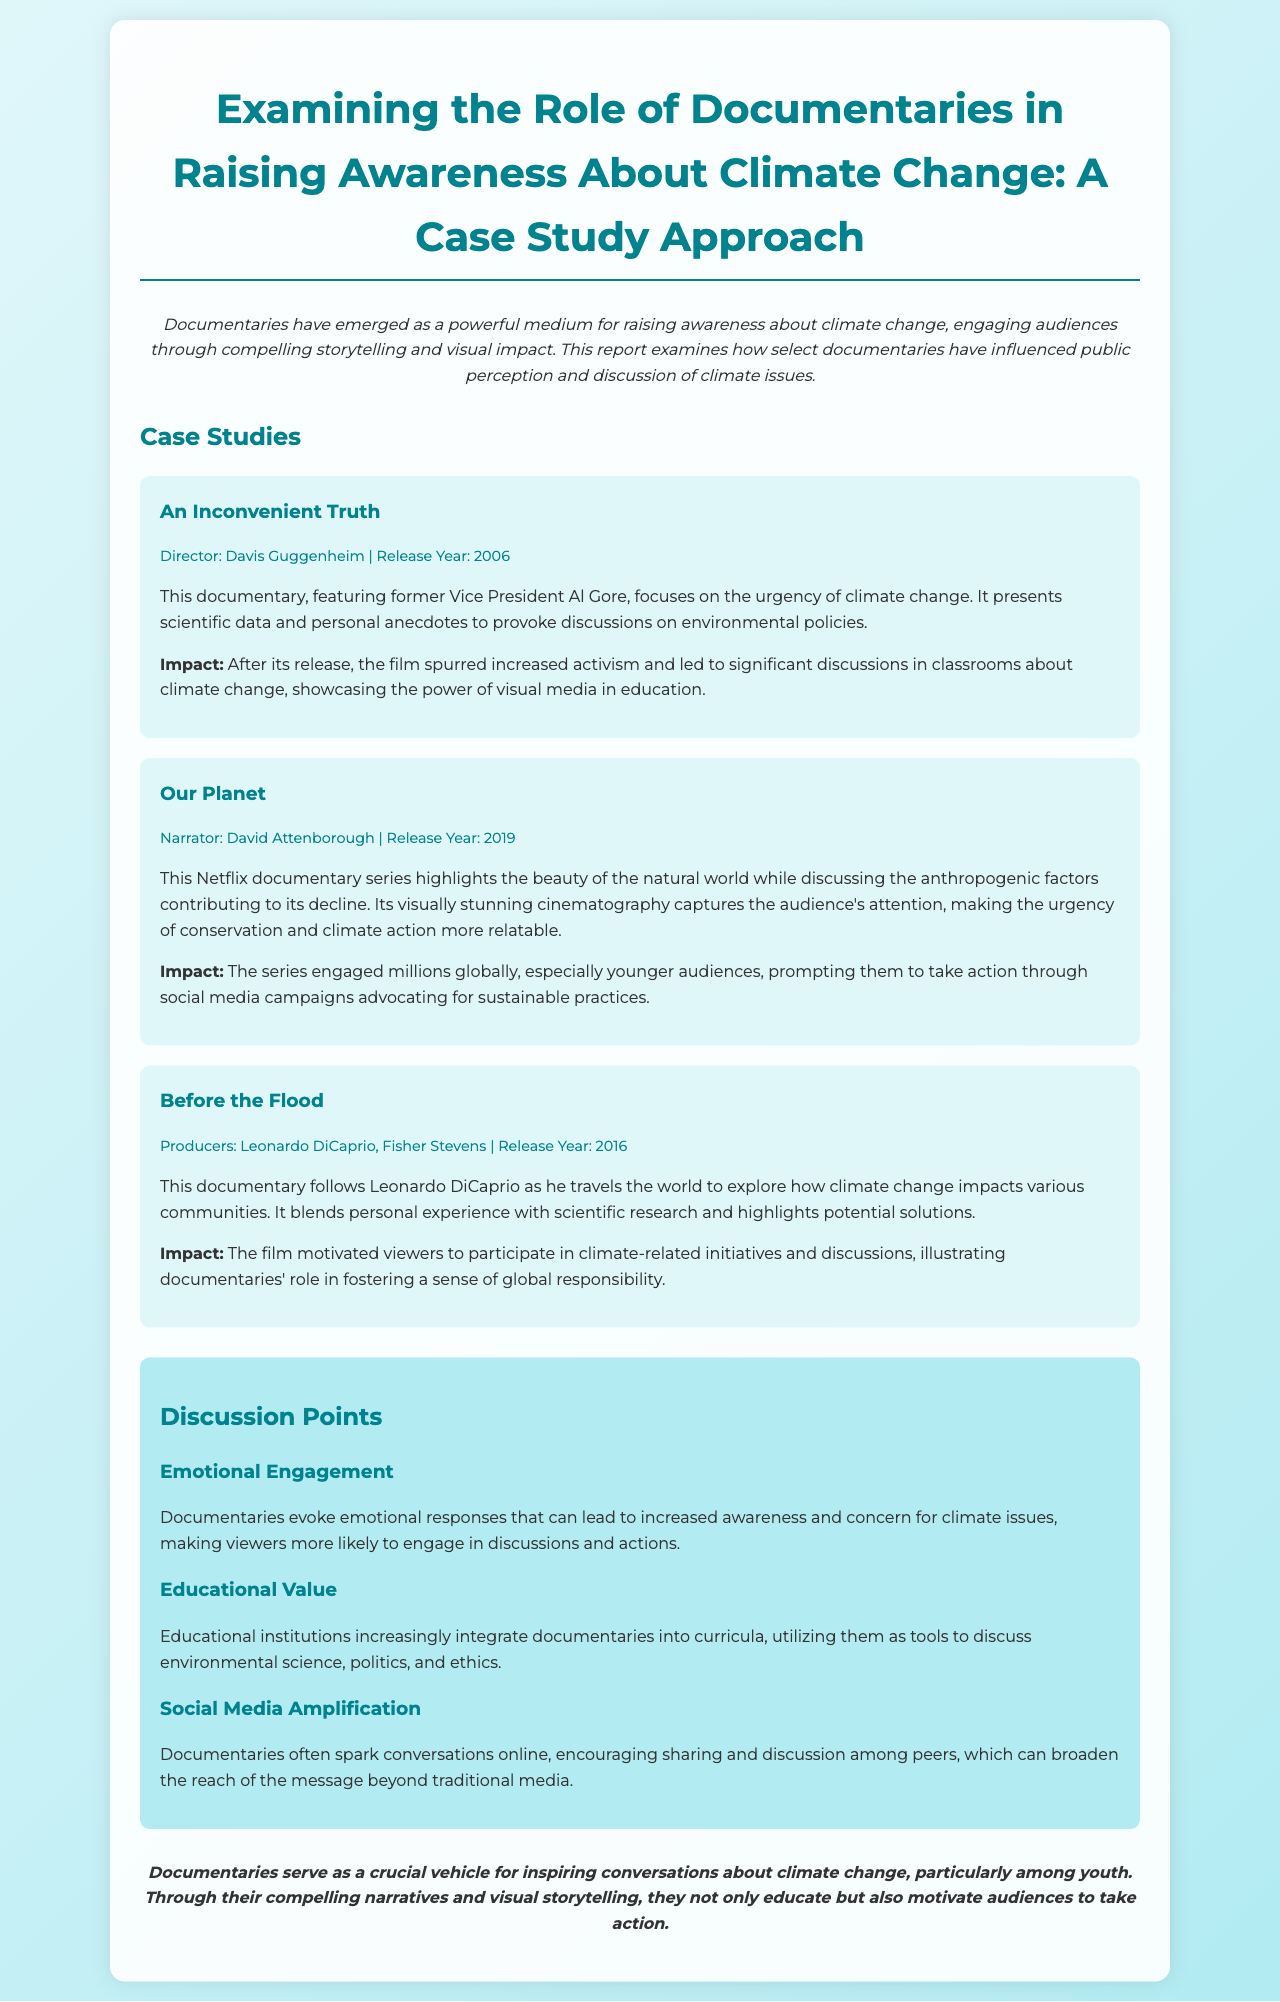what is the title of the report? The title is explicitly stated in the document's header section.
Answer: Examining the Role of Documentaries in Raising Awareness About Climate Change: A Case Study Approach who directed "An Inconvenient Truth"? The document includes the director's name in the case study section dedicated to the documentary.
Answer: Davis Guggenheim what year was "Our Planet" released? The release year is provided within the case study section of the report.
Answer: 2019 which actor produced "Before the Flood"? The document mentions the producer's name in the relevant case study description.
Answer: Leonardo DiCaprio what is one of the emotional effects of documentaries on viewers? The document states the impact of documentaries in terms of audience engagement in the discussion points section.
Answer: Emotional responses how do educational institutions utilize documentaries according to the report? The document indicates how institutions employ documentaries in educational contexts in the discussion points section.
Answer: As tools which documentary is narrated by David Attenborough? The document explicitly states the narrator within the specific case study.
Answer: Our Planet what is a key impact of "An Inconvenient Truth"? The document highlights the specific impact of that documentary in its case study description.
Answer: Increased activism what theme is common among the discussed documentaries? This theme is inferred from the collective descriptions provided in the case studies.
Answer: Climate change 